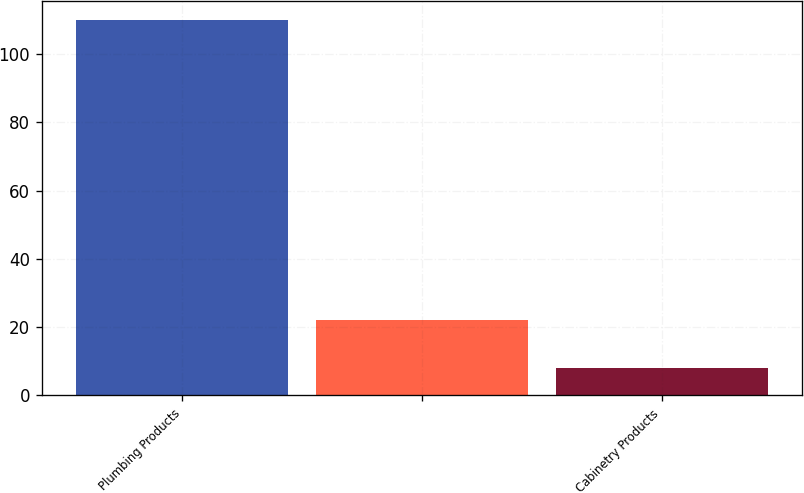Convert chart. <chart><loc_0><loc_0><loc_500><loc_500><bar_chart><fcel>Plumbing Products<fcel>Unnamed: 1<fcel>Cabinetry Products<nl><fcel>110<fcel>22<fcel>8<nl></chart> 